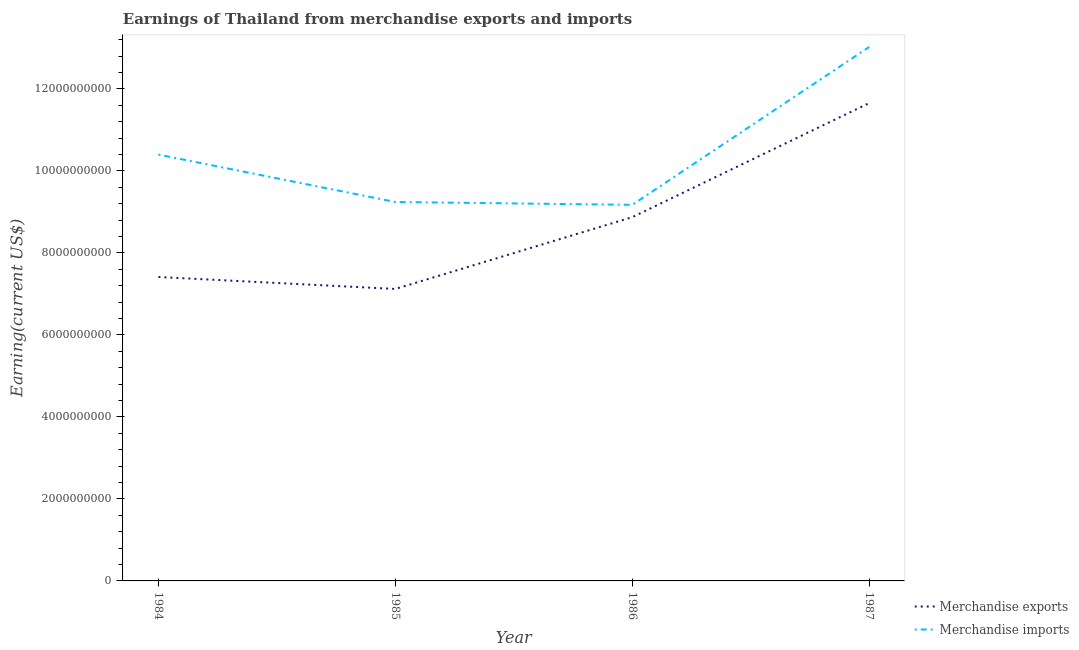How many different coloured lines are there?
Offer a terse response. 2. Is the number of lines equal to the number of legend labels?
Ensure brevity in your answer.  Yes. What is the earnings from merchandise exports in 1987?
Ensure brevity in your answer.  1.17e+1. Across all years, what is the maximum earnings from merchandise imports?
Offer a very short reply. 1.30e+1. Across all years, what is the minimum earnings from merchandise exports?
Provide a short and direct response. 7.12e+09. In which year was the earnings from merchandise imports maximum?
Your answer should be compact. 1987. In which year was the earnings from merchandise imports minimum?
Offer a terse response. 1986. What is the total earnings from merchandise imports in the graph?
Keep it short and to the point. 4.18e+1. What is the difference between the earnings from merchandise exports in 1984 and that in 1987?
Provide a short and direct response. -4.24e+09. What is the difference between the earnings from merchandise exports in 1986 and the earnings from merchandise imports in 1984?
Ensure brevity in your answer.  -1.53e+09. What is the average earnings from merchandise imports per year?
Give a very brief answer. 1.05e+1. In the year 1984, what is the difference between the earnings from merchandise imports and earnings from merchandise exports?
Your answer should be very brief. 2.98e+09. What is the ratio of the earnings from merchandise imports in 1984 to that in 1985?
Your answer should be very brief. 1.13. Is the earnings from merchandise exports in 1984 less than that in 1985?
Keep it short and to the point. No. What is the difference between the highest and the second highest earnings from merchandise exports?
Provide a succinct answer. 2.78e+09. What is the difference between the highest and the lowest earnings from merchandise imports?
Your answer should be compact. 3.85e+09. In how many years, is the earnings from merchandise exports greater than the average earnings from merchandise exports taken over all years?
Make the answer very short. 2. Is the sum of the earnings from merchandise imports in 1984 and 1985 greater than the maximum earnings from merchandise exports across all years?
Your answer should be compact. Yes. Does the earnings from merchandise imports monotonically increase over the years?
Your answer should be compact. No. Is the earnings from merchandise exports strictly less than the earnings from merchandise imports over the years?
Your answer should be very brief. Yes. How many years are there in the graph?
Keep it short and to the point. 4. What is the difference between two consecutive major ticks on the Y-axis?
Make the answer very short. 2.00e+09. Are the values on the major ticks of Y-axis written in scientific E-notation?
Offer a terse response. No. Does the graph contain grids?
Offer a terse response. No. Where does the legend appear in the graph?
Provide a short and direct response. Bottom right. How are the legend labels stacked?
Provide a succinct answer. Vertical. What is the title of the graph?
Your answer should be compact. Earnings of Thailand from merchandise exports and imports. What is the label or title of the Y-axis?
Offer a terse response. Earning(current US$). What is the Earning(current US$) of Merchandise exports in 1984?
Provide a succinct answer. 7.41e+09. What is the Earning(current US$) in Merchandise imports in 1984?
Provide a succinct answer. 1.04e+1. What is the Earning(current US$) of Merchandise exports in 1985?
Ensure brevity in your answer.  7.12e+09. What is the Earning(current US$) in Merchandise imports in 1985?
Provide a short and direct response. 9.24e+09. What is the Earning(current US$) in Merchandise exports in 1986?
Keep it short and to the point. 8.87e+09. What is the Earning(current US$) of Merchandise imports in 1986?
Provide a succinct answer. 9.17e+09. What is the Earning(current US$) of Merchandise exports in 1987?
Provide a succinct answer. 1.17e+1. What is the Earning(current US$) of Merchandise imports in 1987?
Provide a succinct answer. 1.30e+1. Across all years, what is the maximum Earning(current US$) of Merchandise exports?
Offer a very short reply. 1.17e+1. Across all years, what is the maximum Earning(current US$) of Merchandise imports?
Make the answer very short. 1.30e+1. Across all years, what is the minimum Earning(current US$) in Merchandise exports?
Give a very brief answer. 7.12e+09. Across all years, what is the minimum Earning(current US$) in Merchandise imports?
Offer a very short reply. 9.17e+09. What is the total Earning(current US$) of Merchandise exports in the graph?
Make the answer very short. 3.51e+1. What is the total Earning(current US$) of Merchandise imports in the graph?
Give a very brief answer. 4.18e+1. What is the difference between the Earning(current US$) of Merchandise exports in 1984 and that in 1985?
Keep it short and to the point. 2.92e+08. What is the difference between the Earning(current US$) in Merchandise imports in 1984 and that in 1985?
Provide a short and direct response. 1.16e+09. What is the difference between the Earning(current US$) in Merchandise exports in 1984 and that in 1986?
Your response must be concise. -1.46e+09. What is the difference between the Earning(current US$) of Merchandise imports in 1984 and that in 1986?
Your response must be concise. 1.22e+09. What is the difference between the Earning(current US$) of Merchandise exports in 1984 and that in 1987?
Your answer should be very brief. -4.24e+09. What is the difference between the Earning(current US$) in Merchandise imports in 1984 and that in 1987?
Offer a terse response. -2.62e+09. What is the difference between the Earning(current US$) of Merchandise exports in 1985 and that in 1986?
Keep it short and to the point. -1.75e+09. What is the difference between the Earning(current US$) in Merchandise imports in 1985 and that in 1986?
Offer a terse response. 6.90e+07. What is the difference between the Earning(current US$) in Merchandise exports in 1985 and that in 1987?
Offer a terse response. -4.53e+09. What is the difference between the Earning(current US$) in Merchandise imports in 1985 and that in 1987?
Provide a succinct answer. -3.78e+09. What is the difference between the Earning(current US$) in Merchandise exports in 1986 and that in 1987?
Provide a short and direct response. -2.78e+09. What is the difference between the Earning(current US$) in Merchandise imports in 1986 and that in 1987?
Ensure brevity in your answer.  -3.85e+09. What is the difference between the Earning(current US$) in Merchandise exports in 1984 and the Earning(current US$) in Merchandise imports in 1985?
Offer a very short reply. -1.83e+09. What is the difference between the Earning(current US$) in Merchandise exports in 1984 and the Earning(current US$) in Merchandise imports in 1986?
Give a very brief answer. -1.76e+09. What is the difference between the Earning(current US$) in Merchandise exports in 1984 and the Earning(current US$) in Merchandise imports in 1987?
Your answer should be compact. -5.61e+09. What is the difference between the Earning(current US$) of Merchandise exports in 1985 and the Earning(current US$) of Merchandise imports in 1986?
Make the answer very short. -2.05e+09. What is the difference between the Earning(current US$) in Merchandise exports in 1985 and the Earning(current US$) in Merchandise imports in 1987?
Provide a short and direct response. -5.90e+09. What is the difference between the Earning(current US$) of Merchandise exports in 1986 and the Earning(current US$) of Merchandise imports in 1987?
Ensure brevity in your answer.  -4.15e+09. What is the average Earning(current US$) of Merchandise exports per year?
Give a very brief answer. 8.76e+09. What is the average Earning(current US$) in Merchandise imports per year?
Give a very brief answer. 1.05e+1. In the year 1984, what is the difference between the Earning(current US$) of Merchandise exports and Earning(current US$) of Merchandise imports?
Your answer should be very brief. -2.98e+09. In the year 1985, what is the difference between the Earning(current US$) of Merchandise exports and Earning(current US$) of Merchandise imports?
Give a very brief answer. -2.12e+09. In the year 1986, what is the difference between the Earning(current US$) in Merchandise exports and Earning(current US$) in Merchandise imports?
Offer a very short reply. -3.01e+08. In the year 1987, what is the difference between the Earning(current US$) in Merchandise exports and Earning(current US$) in Merchandise imports?
Ensure brevity in your answer.  -1.37e+09. What is the ratio of the Earning(current US$) in Merchandise exports in 1984 to that in 1985?
Give a very brief answer. 1.04. What is the ratio of the Earning(current US$) in Merchandise imports in 1984 to that in 1985?
Keep it short and to the point. 1.13. What is the ratio of the Earning(current US$) of Merchandise exports in 1984 to that in 1986?
Your response must be concise. 0.84. What is the ratio of the Earning(current US$) in Merchandise imports in 1984 to that in 1986?
Offer a terse response. 1.13. What is the ratio of the Earning(current US$) in Merchandise exports in 1984 to that in 1987?
Give a very brief answer. 0.64. What is the ratio of the Earning(current US$) in Merchandise imports in 1984 to that in 1987?
Make the answer very short. 0.8. What is the ratio of the Earning(current US$) of Merchandise exports in 1985 to that in 1986?
Keep it short and to the point. 0.8. What is the ratio of the Earning(current US$) in Merchandise imports in 1985 to that in 1986?
Keep it short and to the point. 1.01. What is the ratio of the Earning(current US$) of Merchandise exports in 1985 to that in 1987?
Give a very brief answer. 0.61. What is the ratio of the Earning(current US$) of Merchandise imports in 1985 to that in 1987?
Provide a succinct answer. 0.71. What is the ratio of the Earning(current US$) of Merchandise exports in 1986 to that in 1987?
Ensure brevity in your answer.  0.76. What is the ratio of the Earning(current US$) of Merchandise imports in 1986 to that in 1987?
Give a very brief answer. 0.7. What is the difference between the highest and the second highest Earning(current US$) of Merchandise exports?
Give a very brief answer. 2.78e+09. What is the difference between the highest and the second highest Earning(current US$) in Merchandise imports?
Provide a short and direct response. 2.62e+09. What is the difference between the highest and the lowest Earning(current US$) in Merchandise exports?
Offer a terse response. 4.53e+09. What is the difference between the highest and the lowest Earning(current US$) of Merchandise imports?
Provide a succinct answer. 3.85e+09. 